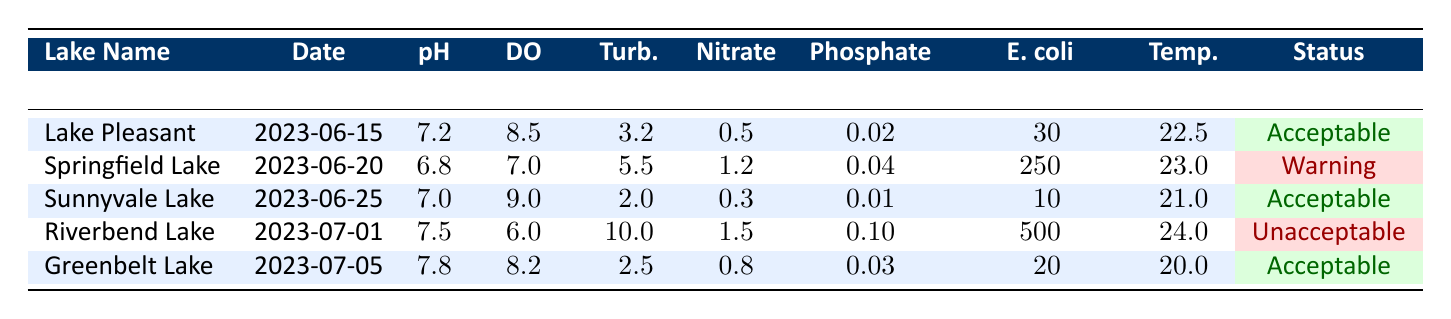What is the pH level of Springfield Lake? The pH level of Springfield Lake is found in the third column of its row, which lists it as 6.8.
Answer: 6.8 Which lake has the highest concentration of E. coli? Looking at the E. coli concentrations in the last column, Riverbend Lake shows 500 CFU/100mL, which is higher than the others.
Answer: Riverbend Lake What is the average temperature of all the lakes tested? To calculate, we sum the temperatures: (22.5 + 23.0 + 21.0 + 24.0 + 20.0) = 110.5. There are 5 lakes, so the average is 110.5/5 = 22.1.
Answer: 22.1 Is the water quality status of Sunnyvale Lake acceptable? Checking the status column, it shows that Sunnyvale Lake is labeled as "Acceptable."
Answer: Yes Which lake has a status of "Warning" and what is its nitrate level? Springfield Lake has a status of "Warning" and its nitrate level is listed as 1.2 mg/L in the corresponding column.
Answer: Springfield Lake; 1.2 mg/L Calculate the difference in dissolved oxygen between Lake Pleasant and Riverbend Lake. Lake Pleasant has a dissolved oxygen level of 8.5 mg/L and Riverbend Lake has 6.0 mg/L. The difference is 8.5 - 6.0 = 2.5 mg/L.
Answer: 2.5 mg/L Do all lakes have a dissolved oxygen level above 6 mg/L? Reviewing the dissolved oxygen levels, Riverbend Lake has a level of 6.0 mg/L, which is not above 6 mg/L. Therefore, the answer is no.
Answer: No What is the turbidity level of the lake with the most acceptable water quality status? Among the lakes with an "Acceptable" status, Lake Pleasant has a turbidity level of 3.2 NTU, which is recorded in its respective column.
Answer: 3.2 NTU How many lakes have a phosphate level greater than 0.02 mg/L? Lake Springfield has a phosphate level of 0.04 mg/L and Riverbend Lake has 0.10 mg/L. Therefore, there are 2 lakes (Springfield and Riverbend).
Answer: 2 